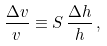<formula> <loc_0><loc_0><loc_500><loc_500>\frac { \Delta v } { v } \equiv S \, \frac { \Delta h } { h } \, ,</formula> 